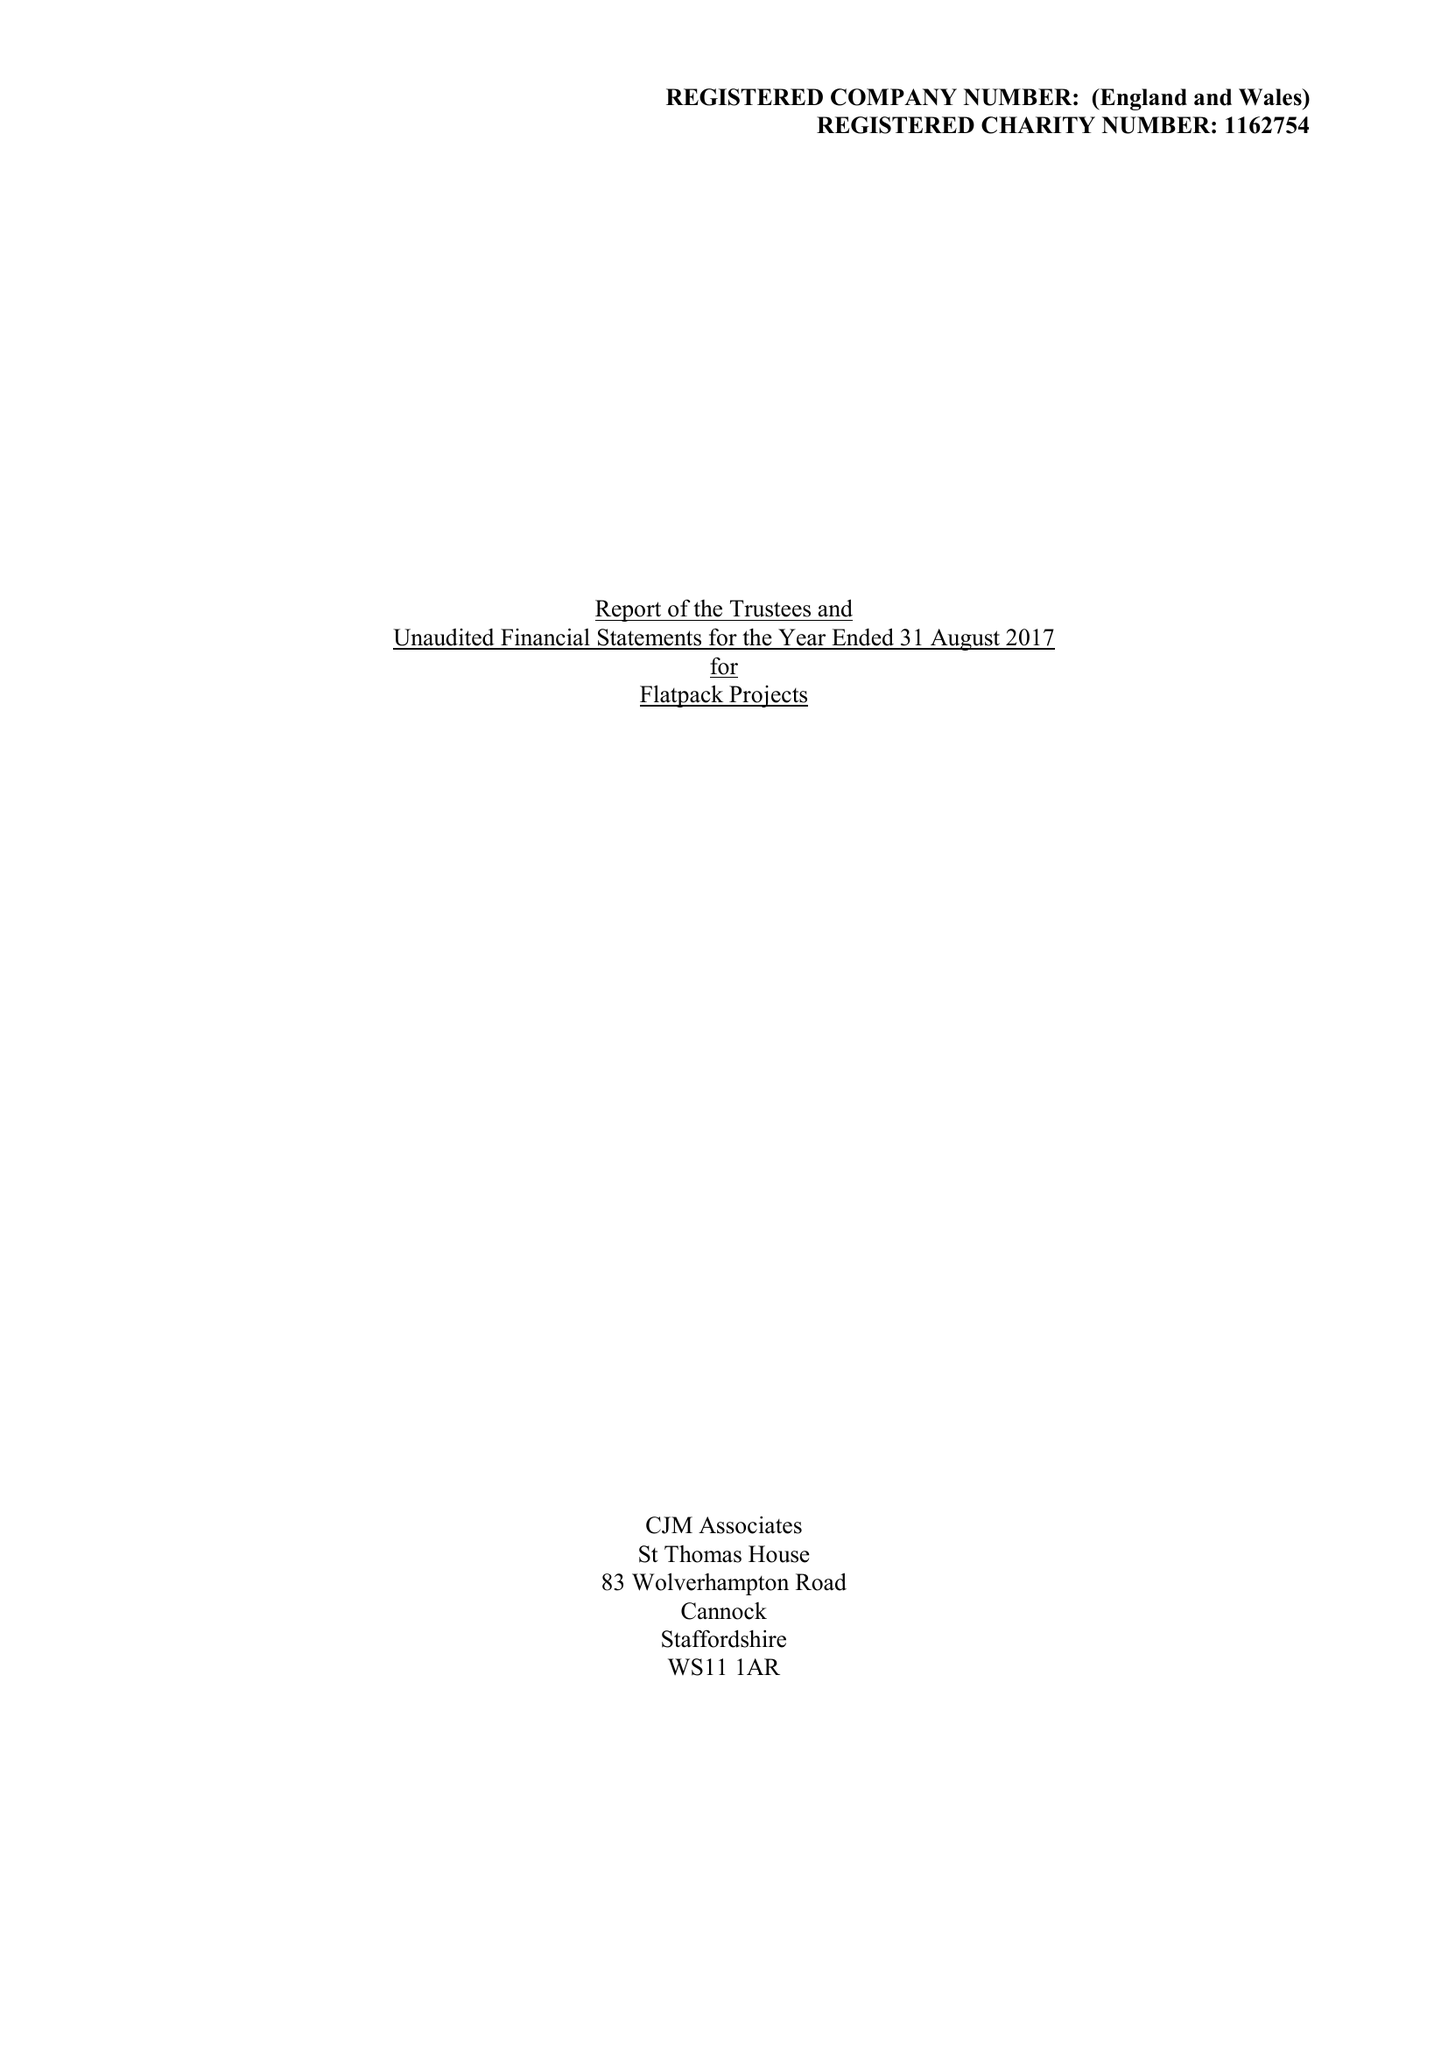What is the value for the charity_number?
Answer the question using a single word or phrase. 1162754 